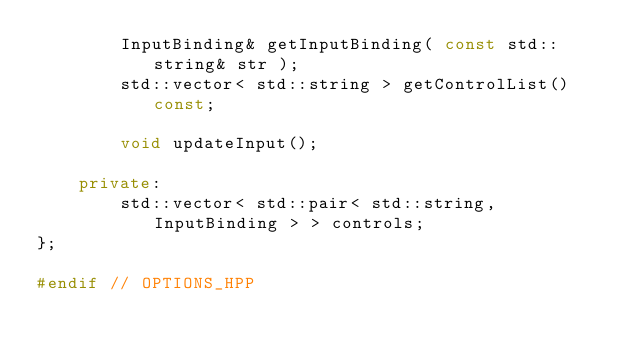Convert code to text. <code><loc_0><loc_0><loc_500><loc_500><_C++_>		InputBinding& getInputBinding( const std::string& str );
		std::vector< std::string > getControlList() const;
		
		void updateInput();
	
	private:
		std::vector< std::pair< std::string, InputBinding > > controls;
};

#endif // OPTIONS_HPP
</code> 